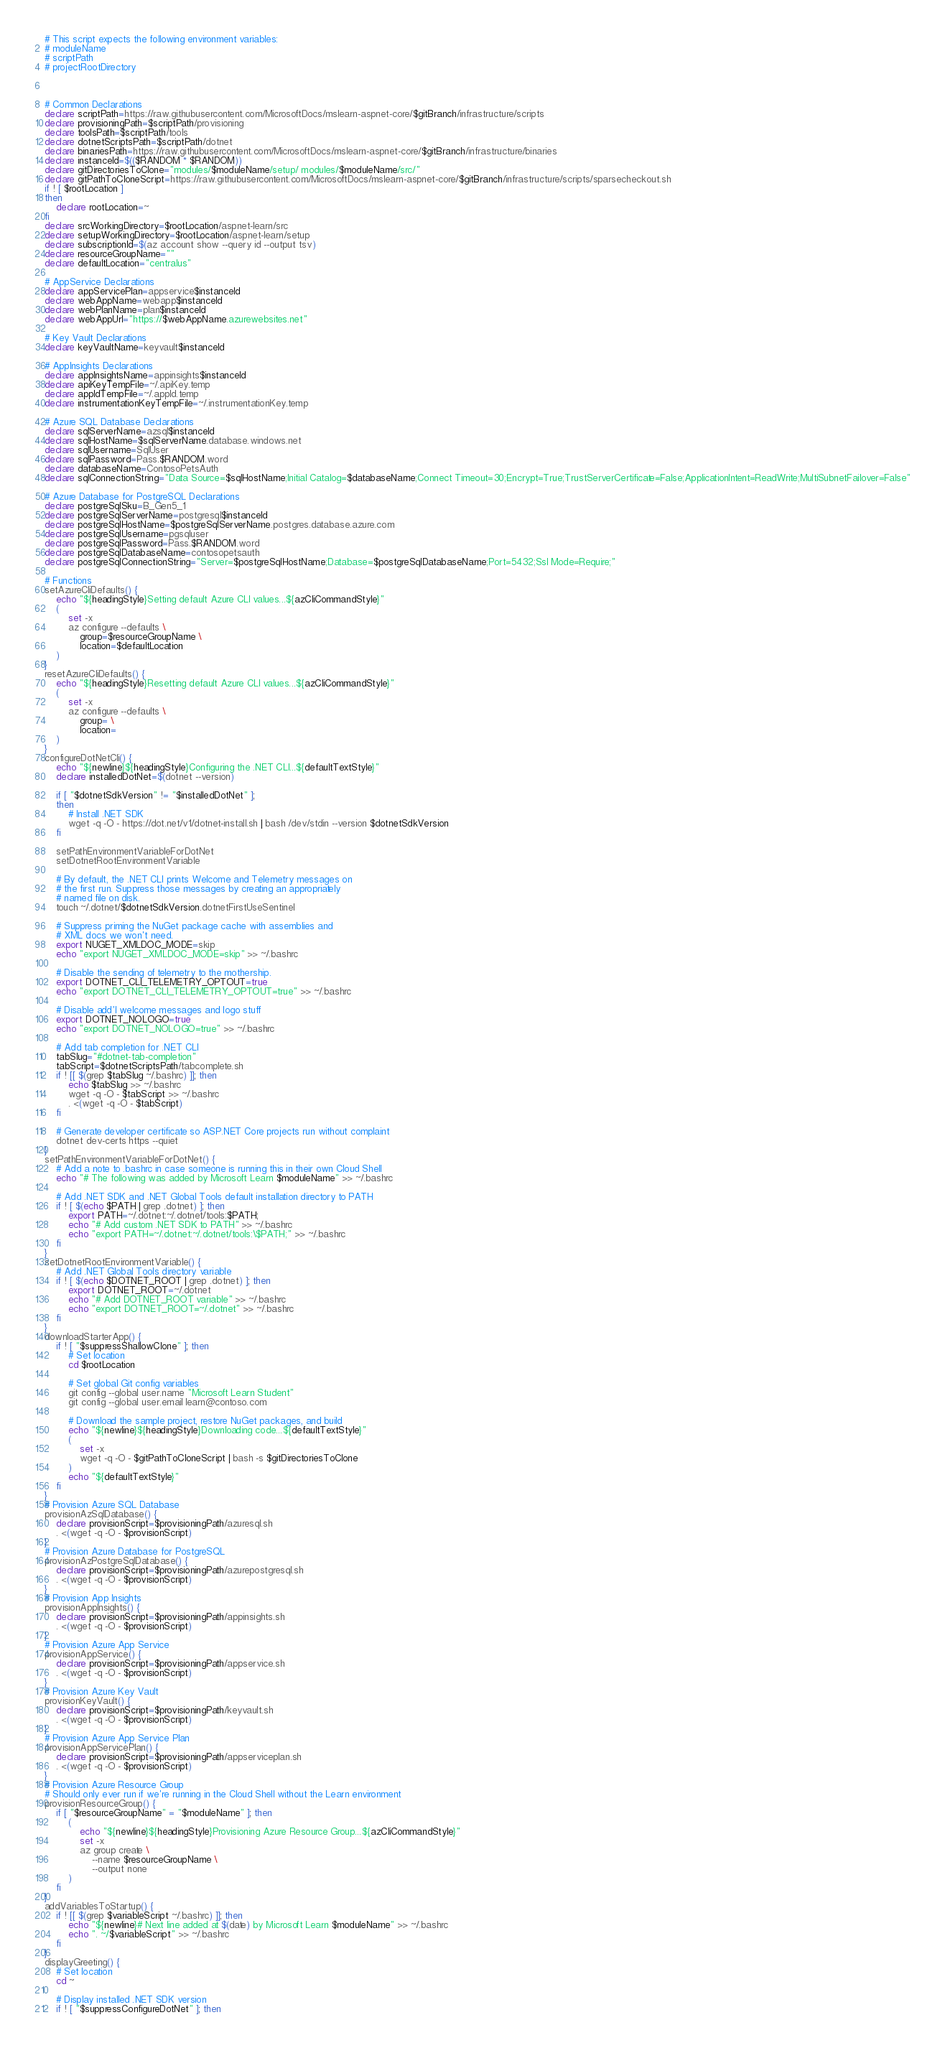<code> <loc_0><loc_0><loc_500><loc_500><_Bash_># This script expects the following environment variables:
# moduleName
# scriptPath
# projectRootDirectory



# Common Declarations
declare scriptPath=https://raw.githubusercontent.com/MicrosoftDocs/mslearn-aspnet-core/$gitBranch/infrastructure/scripts
declare provisioningPath=$scriptPath/provisioning
declare toolsPath=$scriptPath/tools
declare dotnetScriptsPath=$scriptPath/dotnet
declare binariesPath=https://raw.githubusercontent.com/MicrosoftDocs/mslearn-aspnet-core/$gitBranch/infrastructure/binaries
declare instanceId=$(($RANDOM * $RANDOM))
declare gitDirectoriesToClone="modules/$moduleName/setup/ modules/$moduleName/src/"
declare gitPathToCloneScript=https://raw.githubusercontent.com/MicrosoftDocs/mslearn-aspnet-core/$gitBranch/infrastructure/scripts/sparsecheckout.sh
if ! [ $rootLocation ]
then
    declare rootLocation=~
fi
declare srcWorkingDirectory=$rootLocation/aspnet-learn/src
declare setupWorkingDirectory=$rootLocation/aspnet-learn/setup
declare subscriptionId=$(az account show --query id --output tsv)
declare resourceGroupName=""
declare defaultLocation="centralus"

# AppService Declarations
declare appServicePlan=appservice$instanceId
declare webAppName=webapp$instanceId
declare webPlanName=plan$instanceId
declare webAppUrl="https://$webAppName.azurewebsites.net"

# Key Vault Declarations
declare keyVaultName=keyvault$instanceId

# AppInsights Declarations
declare appInsightsName=appinsights$instanceId
declare apiKeyTempFile=~/.apiKey.temp
declare appIdTempFile=~/.appId.temp
declare instrumentationKeyTempFile=~/.instrumentationKey.temp

# Azure SQL Database Declarations
declare sqlServerName=azsql$instanceId
declare sqlHostName=$sqlServerName.database.windows.net
declare sqlUsername=SqlUser
declare sqlPassword=Pass.$RANDOM.word
declare databaseName=ContosoPetsAuth
declare sqlConnectionString="Data Source=$sqlHostName;Initial Catalog=$databaseName;Connect Timeout=30;Encrypt=True;TrustServerCertificate=False;ApplicationIntent=ReadWrite;MultiSubnetFailover=False"

# Azure Database for PostgreSQL Declarations
declare postgreSqlSku=B_Gen5_1
declare postgreSqlServerName=postgresql$instanceId
declare postgreSqlHostName=$postgreSqlServerName.postgres.database.azure.com
declare postgreSqlUsername=pgsqluser
declare postgreSqlPassword=Pass.$RANDOM.word
declare postgreSqlDatabaseName=contosopetsauth
declare postgreSqlConnectionString="Server=$postgreSqlHostName;Database=$postgreSqlDatabaseName;Port=5432;Ssl Mode=Require;"

# Functions
setAzureCliDefaults() {
    echo "${headingStyle}Setting default Azure CLI values...${azCliCommandStyle}"
    (
        set -x
        az configure --defaults \
            group=$resourceGroupName \
            location=$defaultLocation
    )
}
resetAzureCliDefaults() {
    echo "${headingStyle}Resetting default Azure CLI values...${azCliCommandStyle}"
    (
        set -x
        az configure --defaults \
            group= \
            location=
    )
}
configureDotNetCli() {
    echo "${newline}${headingStyle}Configuring the .NET CLI...${defaultTextStyle}"
    declare installedDotNet=$(dotnet --version)

    if [ "$dotnetSdkVersion" != "$installedDotNet" ];
    then
        # Install .NET SDK
        wget -q -O - https://dot.net/v1/dotnet-install.sh | bash /dev/stdin --version $dotnetSdkVersion
    fi

    setPathEnvironmentVariableForDotNet
    setDotnetRootEnvironmentVariable

    # By default, the .NET CLI prints Welcome and Telemetry messages on
    # the first run. Suppress those messages by creating an appropriately
    # named file on disk.
    touch ~/.dotnet/$dotnetSdkVersion.dotnetFirstUseSentinel

    # Suppress priming the NuGet package cache with assemblies and 
    # XML docs we won't need.
    export NUGET_XMLDOC_MODE=skip
    echo "export NUGET_XMLDOC_MODE=skip" >> ~/.bashrc
    
    # Disable the sending of telemetry to the mothership.
    export DOTNET_CLI_TELEMETRY_OPTOUT=true
    echo "export DOTNET_CLI_TELEMETRY_OPTOUT=true" >> ~/.bashrc

    # Disable add'l welcome messages and logo stuff
    export DOTNET_NOLOGO=true
    echo "export DOTNET_NOLOGO=true" >> ~/.bashrc

    # Add tab completion for .NET CLI
    tabSlug="#dotnet-tab-completion"
    tabScript=$dotnetScriptsPath/tabcomplete.sh
    if ! [[ $(grep $tabSlug ~/.bashrc) ]]; then
        echo $tabSlug >> ~/.bashrc
        wget -q -O - $tabScript >> ~/.bashrc
        . <(wget -q -O - $tabScript)
    fi
    
    # Generate developer certificate so ASP.NET Core projects run without complaint
    dotnet dev-certs https --quiet
}
setPathEnvironmentVariableForDotNet() {
    # Add a note to .bashrc in case someone is running this in their own Cloud Shell
    echo "# The following was added by Microsoft Learn $moduleName" >> ~/.bashrc

    # Add .NET SDK and .NET Global Tools default installation directory to PATH
    if ! [ $(echo $PATH | grep .dotnet) ]; then 
        export PATH=~/.dotnet:~/.dotnet/tools:$PATH; 
        echo "# Add custom .NET SDK to PATH" >> ~/.bashrc
        echo "export PATH=~/.dotnet:~/.dotnet/tools:\$PATH;" >> ~/.bashrc
    fi
}
setDotnetRootEnvironmentVariable() {
    # Add .NET Global Tools directory variable
    if ! [ $(echo $DOTNET_ROOT | grep .dotnet) ]; then 
        export DOTNET_ROOT=~/.dotnet
        echo "# Add DOTNET_ROOT variable" >> ~/.bashrc
        echo "export DOTNET_ROOT=~/.dotnet" >> ~/.bashrc
    fi
}
downloadStarterApp() {
    if ! [ "$suppressShallowClone" ]; then
        # Set location
        cd $rootLocation

        # Set global Git config variables
        git config --global user.name "Microsoft Learn Student"
        git config --global user.email learn@contoso.com
        
        # Download the sample project, restore NuGet packages, and build
        echo "${newline}${headingStyle}Downloading code...${defaultTextStyle}"
        (
            set -x
            wget -q -O - $gitPathToCloneScript | bash -s $gitDirectoriesToClone
        )
        echo "${defaultTextStyle}"
    fi
}
# Provision Azure SQL Database
provisionAzSqlDatabase() {
    declare provisionScript=$provisioningPath/azuresql.sh
    . <(wget -q -O - $provisionScript)
}
# Provision Azure Database for PostgreSQL
provisionAzPostgreSqlDatabase() {
    declare provisionScript=$provisioningPath/azurepostgresql.sh
    . <(wget -q -O - $provisionScript)
}
# Provision App Insights
provisionAppInsights() {
    declare provisionScript=$provisioningPath/appinsights.sh
    . <(wget -q -O - $provisionScript)
}
# Provision Azure App Service
provisionAppService() {
    declare provisionScript=$provisioningPath/appservice.sh
    . <(wget -q -O - $provisionScript)
}
# Provision Azure Key Vault
provisionKeyVault() {
    declare provisionScript=$provisioningPath/keyvault.sh
    . <(wget -q -O - $provisionScript)
}
# Provision Azure App Service Plan
provisionAppServicePlan() {
    declare provisionScript=$provisioningPath/appserviceplan.sh
    . <(wget -q -O - $provisionScript)
}
# Provision Azure Resource Group
# Should only ever run if we're running in the Cloud Shell without the Learn environment
provisionResourceGroup() {
    if [ "$resourceGroupName" = "$moduleName" ]; then
        (
            echo "${newline}${headingStyle}Provisioning Azure Resource Group...${azCliCommandStyle}"
            set -x
            az group create \
                --name $resourceGroupName \
                --output none
        )
    fi
}
addVariablesToStartup() {
    if ! [[ $(grep $variableScript ~/.bashrc) ]]; then
        echo "${newline}# Next line added at $(date) by Microsoft Learn $moduleName" >> ~/.bashrc
        echo ". ~/$variableScript" >> ~/.bashrc
    fi 
}
displayGreeting() {
    # Set location
    cd ~

    # Display installed .NET SDK version
    if ! [ "$suppressConfigureDotNet" ]; then</code> 